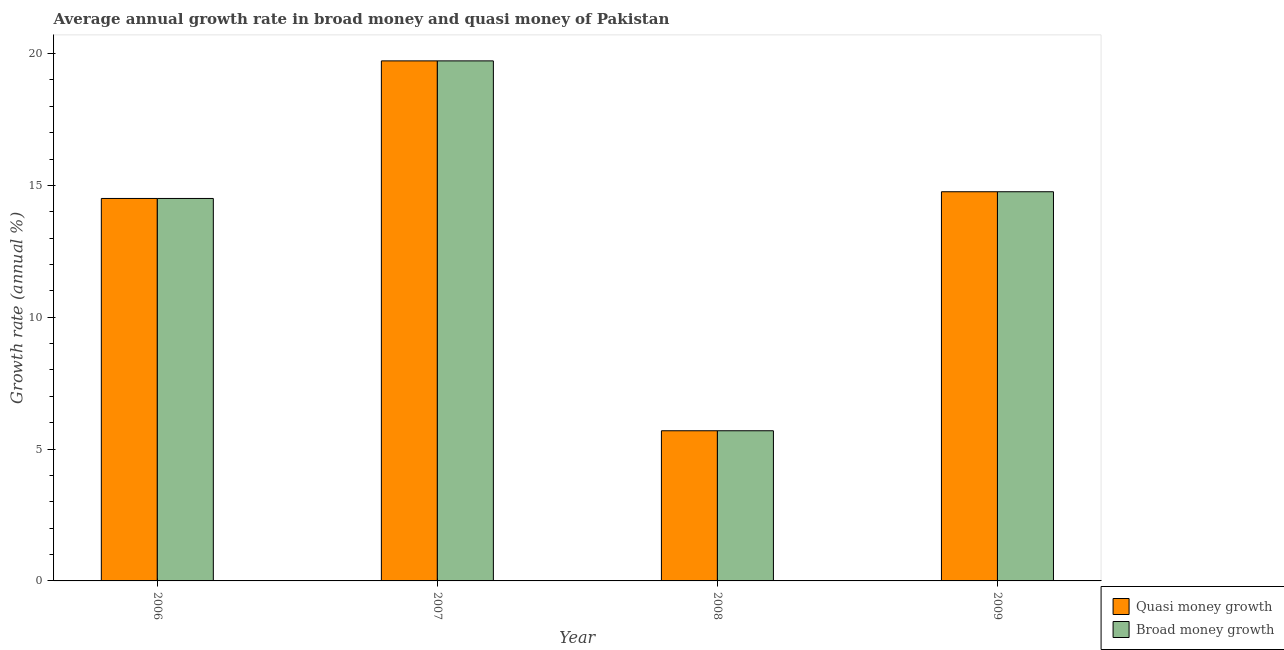How many different coloured bars are there?
Your answer should be compact. 2. How many groups of bars are there?
Provide a short and direct response. 4. Are the number of bars per tick equal to the number of legend labels?
Your answer should be very brief. Yes. Are the number of bars on each tick of the X-axis equal?
Ensure brevity in your answer.  Yes. How many bars are there on the 3rd tick from the left?
Provide a succinct answer. 2. How many bars are there on the 2nd tick from the right?
Ensure brevity in your answer.  2. In how many cases, is the number of bars for a given year not equal to the number of legend labels?
Ensure brevity in your answer.  0. What is the annual growth rate in quasi money in 2007?
Ensure brevity in your answer.  19.72. Across all years, what is the maximum annual growth rate in quasi money?
Offer a terse response. 19.72. Across all years, what is the minimum annual growth rate in broad money?
Give a very brief answer. 5.69. In which year was the annual growth rate in broad money minimum?
Provide a succinct answer. 2008. What is the total annual growth rate in broad money in the graph?
Your answer should be compact. 54.68. What is the difference between the annual growth rate in quasi money in 2006 and that in 2009?
Keep it short and to the point. -0.25. What is the difference between the annual growth rate in quasi money in 2009 and the annual growth rate in broad money in 2007?
Your answer should be compact. -4.96. What is the average annual growth rate in quasi money per year?
Give a very brief answer. 13.67. In the year 2008, what is the difference between the annual growth rate in broad money and annual growth rate in quasi money?
Your response must be concise. 0. In how many years, is the annual growth rate in quasi money greater than 14 %?
Provide a succinct answer. 3. What is the ratio of the annual growth rate in broad money in 2006 to that in 2008?
Keep it short and to the point. 2.55. Is the difference between the annual growth rate in broad money in 2007 and 2008 greater than the difference between the annual growth rate in quasi money in 2007 and 2008?
Provide a succinct answer. No. What is the difference between the highest and the second highest annual growth rate in quasi money?
Offer a terse response. 4.96. What is the difference between the highest and the lowest annual growth rate in broad money?
Provide a succinct answer. 14.03. In how many years, is the annual growth rate in quasi money greater than the average annual growth rate in quasi money taken over all years?
Offer a terse response. 3. Is the sum of the annual growth rate in quasi money in 2006 and 2009 greater than the maximum annual growth rate in broad money across all years?
Offer a terse response. Yes. What does the 1st bar from the left in 2006 represents?
Your response must be concise. Quasi money growth. What does the 1st bar from the right in 2009 represents?
Keep it short and to the point. Broad money growth. How many bars are there?
Offer a terse response. 8. Are all the bars in the graph horizontal?
Offer a very short reply. No. How many years are there in the graph?
Your answer should be very brief. 4. What is the difference between two consecutive major ticks on the Y-axis?
Give a very brief answer. 5. Where does the legend appear in the graph?
Offer a very short reply. Bottom right. How are the legend labels stacked?
Provide a succinct answer. Vertical. What is the title of the graph?
Ensure brevity in your answer.  Average annual growth rate in broad money and quasi money of Pakistan. Does "Rural Population" appear as one of the legend labels in the graph?
Your answer should be very brief. No. What is the label or title of the Y-axis?
Provide a short and direct response. Growth rate (annual %). What is the Growth rate (annual %) in Quasi money growth in 2006?
Provide a succinct answer. 14.5. What is the Growth rate (annual %) of Broad money growth in 2006?
Your answer should be very brief. 14.5. What is the Growth rate (annual %) in Quasi money growth in 2007?
Your answer should be very brief. 19.72. What is the Growth rate (annual %) of Broad money growth in 2007?
Offer a very short reply. 19.72. What is the Growth rate (annual %) in Quasi money growth in 2008?
Make the answer very short. 5.69. What is the Growth rate (annual %) of Broad money growth in 2008?
Your answer should be compact. 5.69. What is the Growth rate (annual %) of Quasi money growth in 2009?
Your response must be concise. 14.76. What is the Growth rate (annual %) in Broad money growth in 2009?
Your answer should be very brief. 14.76. Across all years, what is the maximum Growth rate (annual %) in Quasi money growth?
Your response must be concise. 19.72. Across all years, what is the maximum Growth rate (annual %) in Broad money growth?
Offer a terse response. 19.72. Across all years, what is the minimum Growth rate (annual %) of Quasi money growth?
Your response must be concise. 5.69. Across all years, what is the minimum Growth rate (annual %) in Broad money growth?
Provide a succinct answer. 5.69. What is the total Growth rate (annual %) of Quasi money growth in the graph?
Offer a terse response. 54.68. What is the total Growth rate (annual %) of Broad money growth in the graph?
Your response must be concise. 54.68. What is the difference between the Growth rate (annual %) in Quasi money growth in 2006 and that in 2007?
Make the answer very short. -5.22. What is the difference between the Growth rate (annual %) of Broad money growth in 2006 and that in 2007?
Your answer should be very brief. -5.22. What is the difference between the Growth rate (annual %) of Quasi money growth in 2006 and that in 2008?
Give a very brief answer. 8.81. What is the difference between the Growth rate (annual %) of Broad money growth in 2006 and that in 2008?
Keep it short and to the point. 8.81. What is the difference between the Growth rate (annual %) of Quasi money growth in 2006 and that in 2009?
Give a very brief answer. -0.25. What is the difference between the Growth rate (annual %) of Broad money growth in 2006 and that in 2009?
Offer a terse response. -0.25. What is the difference between the Growth rate (annual %) of Quasi money growth in 2007 and that in 2008?
Your response must be concise. 14.03. What is the difference between the Growth rate (annual %) of Broad money growth in 2007 and that in 2008?
Make the answer very short. 14.03. What is the difference between the Growth rate (annual %) in Quasi money growth in 2007 and that in 2009?
Provide a short and direct response. 4.96. What is the difference between the Growth rate (annual %) in Broad money growth in 2007 and that in 2009?
Offer a terse response. 4.96. What is the difference between the Growth rate (annual %) of Quasi money growth in 2008 and that in 2009?
Give a very brief answer. -9.06. What is the difference between the Growth rate (annual %) of Broad money growth in 2008 and that in 2009?
Provide a short and direct response. -9.06. What is the difference between the Growth rate (annual %) of Quasi money growth in 2006 and the Growth rate (annual %) of Broad money growth in 2007?
Your answer should be very brief. -5.22. What is the difference between the Growth rate (annual %) in Quasi money growth in 2006 and the Growth rate (annual %) in Broad money growth in 2008?
Give a very brief answer. 8.81. What is the difference between the Growth rate (annual %) of Quasi money growth in 2006 and the Growth rate (annual %) of Broad money growth in 2009?
Offer a very short reply. -0.25. What is the difference between the Growth rate (annual %) in Quasi money growth in 2007 and the Growth rate (annual %) in Broad money growth in 2008?
Provide a succinct answer. 14.03. What is the difference between the Growth rate (annual %) in Quasi money growth in 2007 and the Growth rate (annual %) in Broad money growth in 2009?
Give a very brief answer. 4.96. What is the difference between the Growth rate (annual %) of Quasi money growth in 2008 and the Growth rate (annual %) of Broad money growth in 2009?
Your answer should be compact. -9.06. What is the average Growth rate (annual %) of Quasi money growth per year?
Provide a succinct answer. 13.67. What is the average Growth rate (annual %) in Broad money growth per year?
Keep it short and to the point. 13.67. In the year 2006, what is the difference between the Growth rate (annual %) in Quasi money growth and Growth rate (annual %) in Broad money growth?
Provide a short and direct response. 0. In the year 2007, what is the difference between the Growth rate (annual %) in Quasi money growth and Growth rate (annual %) in Broad money growth?
Your answer should be compact. 0. What is the ratio of the Growth rate (annual %) of Quasi money growth in 2006 to that in 2007?
Your response must be concise. 0.74. What is the ratio of the Growth rate (annual %) in Broad money growth in 2006 to that in 2007?
Ensure brevity in your answer.  0.74. What is the ratio of the Growth rate (annual %) in Quasi money growth in 2006 to that in 2008?
Provide a succinct answer. 2.55. What is the ratio of the Growth rate (annual %) of Broad money growth in 2006 to that in 2008?
Your answer should be compact. 2.55. What is the ratio of the Growth rate (annual %) in Quasi money growth in 2006 to that in 2009?
Make the answer very short. 0.98. What is the ratio of the Growth rate (annual %) of Broad money growth in 2006 to that in 2009?
Your answer should be very brief. 0.98. What is the ratio of the Growth rate (annual %) of Quasi money growth in 2007 to that in 2008?
Make the answer very short. 3.46. What is the ratio of the Growth rate (annual %) in Broad money growth in 2007 to that in 2008?
Make the answer very short. 3.46. What is the ratio of the Growth rate (annual %) of Quasi money growth in 2007 to that in 2009?
Provide a succinct answer. 1.34. What is the ratio of the Growth rate (annual %) of Broad money growth in 2007 to that in 2009?
Provide a short and direct response. 1.34. What is the ratio of the Growth rate (annual %) of Quasi money growth in 2008 to that in 2009?
Provide a succinct answer. 0.39. What is the ratio of the Growth rate (annual %) in Broad money growth in 2008 to that in 2009?
Give a very brief answer. 0.39. What is the difference between the highest and the second highest Growth rate (annual %) of Quasi money growth?
Offer a terse response. 4.96. What is the difference between the highest and the second highest Growth rate (annual %) in Broad money growth?
Make the answer very short. 4.96. What is the difference between the highest and the lowest Growth rate (annual %) of Quasi money growth?
Offer a very short reply. 14.03. What is the difference between the highest and the lowest Growth rate (annual %) in Broad money growth?
Offer a terse response. 14.03. 